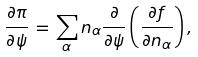<formula> <loc_0><loc_0><loc_500><loc_500>\frac { \partial \pi } { \partial \psi } \, = \, \sum _ { \alpha } n _ { \alpha } \frac { \partial } { \partial \psi } \left ( \frac { \partial f } { \partial n _ { \alpha } } \right ) ,</formula> 